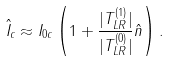Convert formula to latex. <formula><loc_0><loc_0><loc_500><loc_500>\hat { I } _ { c } \approx I _ { 0 c } \left ( 1 + \frac { | T ^ { ( 1 ) } _ { L R } | } { | T ^ { ( 0 ) } _ { L R } | } \hat { n } \right ) .</formula> 